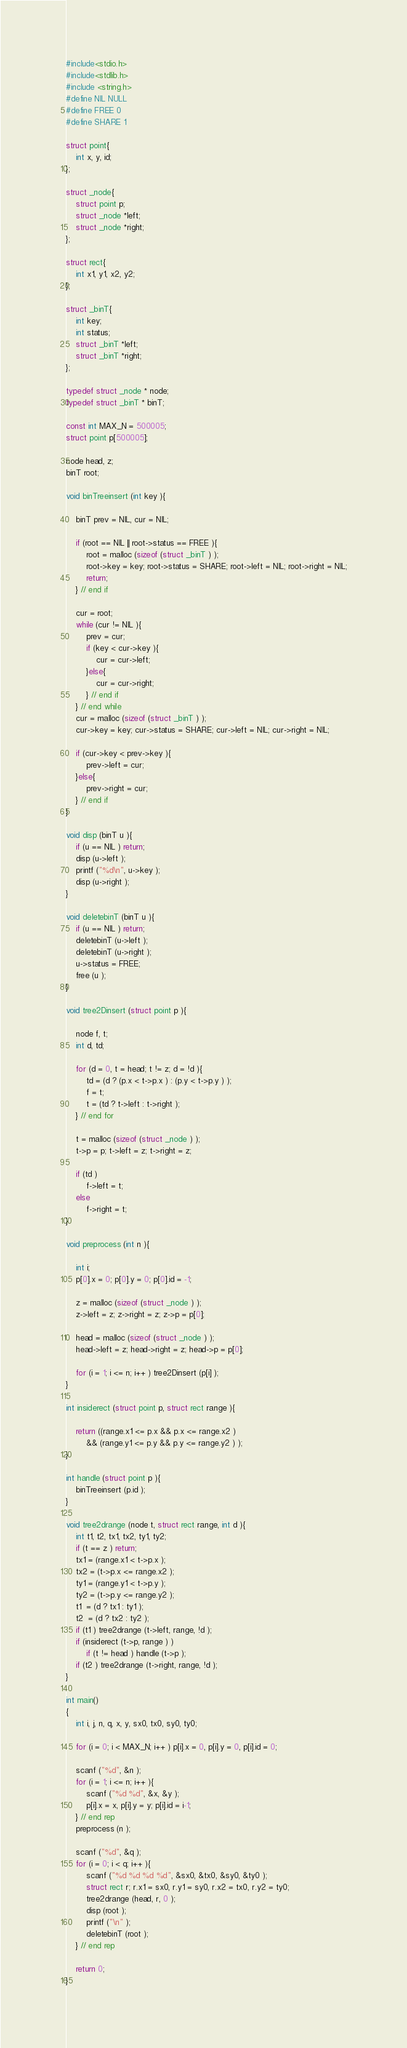<code> <loc_0><loc_0><loc_500><loc_500><_C_>#include<stdio.h>
#include<stdlib.h>
#include <string.h> 
#define NIL NULL
#define FREE 0
#define SHARE 1

struct point{
	int x, y, id;
};

struct _node{
	struct point p;
	struct _node *left;
	struct _node *right;
};

struct rect{
	int x1, y1, x2, y2;
};

struct _binT{
	int key;
	int status;
	struct _binT *left;
	struct _binT *right;
};

typedef struct _node * node;
typedef struct _binT * binT;

const int MAX_N = 500005;
struct point p[500005];

node head, z;
binT root;

void binTreeinsert (int key ){

	binT prev = NIL, cur = NIL;

	if (root == NIL || root->status == FREE ){
		root = malloc (sizeof (struct _binT ) );
		root->key = key; root->status = SHARE; root->left = NIL; root->right = NIL;
		return;
	} // end if

	cur = root;
	while (cur != NIL ){
		prev = cur; 
		if (key < cur->key ){
			cur = cur->left;
		}else{
			cur = cur->right;
		} // end if
	} // end while
	cur = malloc (sizeof (struct _binT ) );
	cur->key = key; cur->status = SHARE; cur->left = NIL; cur->right = NIL;

	if (cur->key < prev->key ){
		prev->left = cur;
	}else{
		prev->right = cur;
	} // end if		
}

void disp (binT u ){
	if (u == NIL ) return;
	disp (u->left );
	printf ("%d\n", u->key );
	disp (u->right );
}

void deletebinT (binT u ){
	if (u == NIL ) return;
	deletebinT (u->left );
	deletebinT (u->right );
	u->status = FREE;
	free (u );
}

void tree2Dinsert (struct point p ){

	node f, t;
	int d, td;

	for (d = 0, t = head; t != z; d = !d ){
		td = (d ? (p.x < t->p.x ) : (p.y < t->p.y ) );
		f = t;
		t = (td ? t->left : t->right );
	} // end for
	
	t = malloc (sizeof (struct _node ) );
	t->p = p; t->left = z; t->right = z;

	if (td )
		f->left = t;
	else
		f->right = t;
}

void preprocess (int n ){

	int i;
	p[0].x = 0; p[0].y = 0; p[0].id = -1;

	z = malloc (sizeof (struct _node ) );
	z->left = z; z->right = z; z->p = p[0];

	head = malloc (sizeof (struct _node ) );
	head->left = z; head->right = z; head->p = p[0];

	for (i = 1; i <= n; i++ ) tree2Dinsert (p[i] );
}

int insiderect (struct point p, struct rect range ){

	return ((range.x1 <= p.x && p.x <= range.x2 )
		&& (range.y1 <= p.y && p.y <= range.y2 ) );
}

int handle (struct point p ){
	binTreeinsert (p.id );
}

void tree2drange (node t, struct rect range, int d ){
	int t1, t2, tx1, tx2, ty1, ty2;
	if (t == z ) return;
	tx1 = (range.x1 < t->p.x );
	tx2 = (t->p.x <= range.x2 );
	ty1 = (range.y1 < t->p.y );
	ty2 = (t->p.y <= range.y2 );
	t1  = (d ? tx1 : ty1 );
	t2  = (d ? tx2 : ty2 );
	if (t1 ) tree2drange (t->left, range, !d );
	if (insiderect (t->p, range ) )
		if (t != head ) handle (t->p );
	if (t2 ) tree2drange (t->right, range, !d );
}

int main()
{
	int i, j, n, q, x, y, sx0, tx0, sy0, ty0;

	for (i = 0; i < MAX_N; i++ ) p[i].x = 0, p[i].y = 0, p[i].id = 0;

	scanf ("%d", &n );
	for (i = 1; i <= n; i++ ){
		scanf ("%d %d", &x, &y );
		p[i].x = x, p[i].y = y; p[i].id = i-1;
	} // end rep
	preprocess (n );

	scanf ("%d", &q );
	for (i = 0; i < q; i++ ){
		scanf ("%d %d %d %d", &sx0, &tx0, &sy0, &ty0 );
		struct rect r; r.x1 = sx0, r.y1 = sy0, r.x2 = tx0, r.y2 = ty0;
		tree2drange (head, r, 0 );
		disp (root );
		printf ("\n" );
		deletebinT (root );
	} // end rep
		
	return 0;
}</code> 